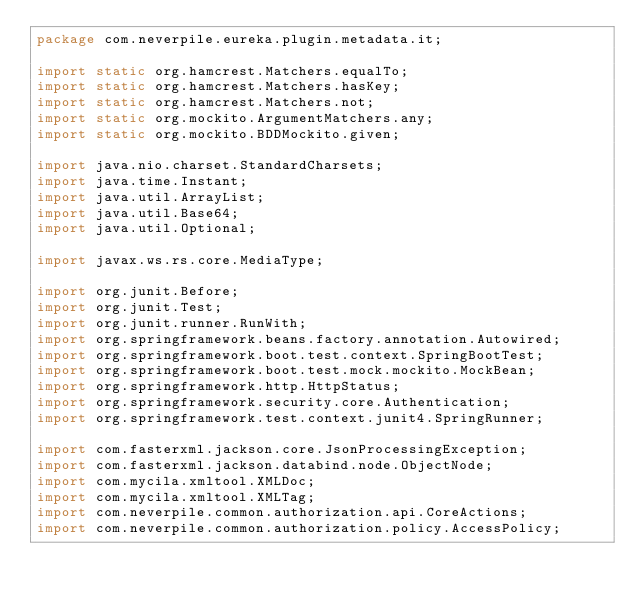<code> <loc_0><loc_0><loc_500><loc_500><_Java_>package com.neverpile.eureka.plugin.metadata.it;

import static org.hamcrest.Matchers.equalTo;
import static org.hamcrest.Matchers.hasKey;
import static org.hamcrest.Matchers.not;
import static org.mockito.ArgumentMatchers.any;
import static org.mockito.BDDMockito.given;

import java.nio.charset.StandardCharsets;
import java.time.Instant;
import java.util.ArrayList;
import java.util.Base64;
import java.util.Optional;

import javax.ws.rs.core.MediaType;

import org.junit.Before;
import org.junit.Test;
import org.junit.runner.RunWith;
import org.springframework.beans.factory.annotation.Autowired;
import org.springframework.boot.test.context.SpringBootTest;
import org.springframework.boot.test.mock.mockito.MockBean;
import org.springframework.http.HttpStatus;
import org.springframework.security.core.Authentication;
import org.springframework.test.context.junit4.SpringRunner;

import com.fasterxml.jackson.core.JsonProcessingException;
import com.fasterxml.jackson.databind.node.ObjectNode;
import com.mycila.xmltool.XMLDoc;
import com.mycila.xmltool.XMLTag;
import com.neverpile.common.authorization.api.CoreActions;
import com.neverpile.common.authorization.policy.AccessPolicy;</code> 